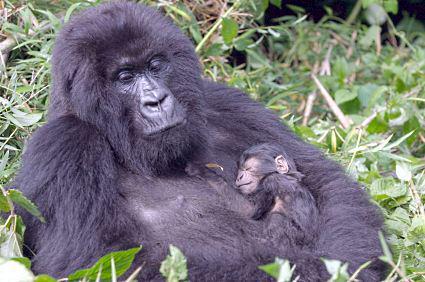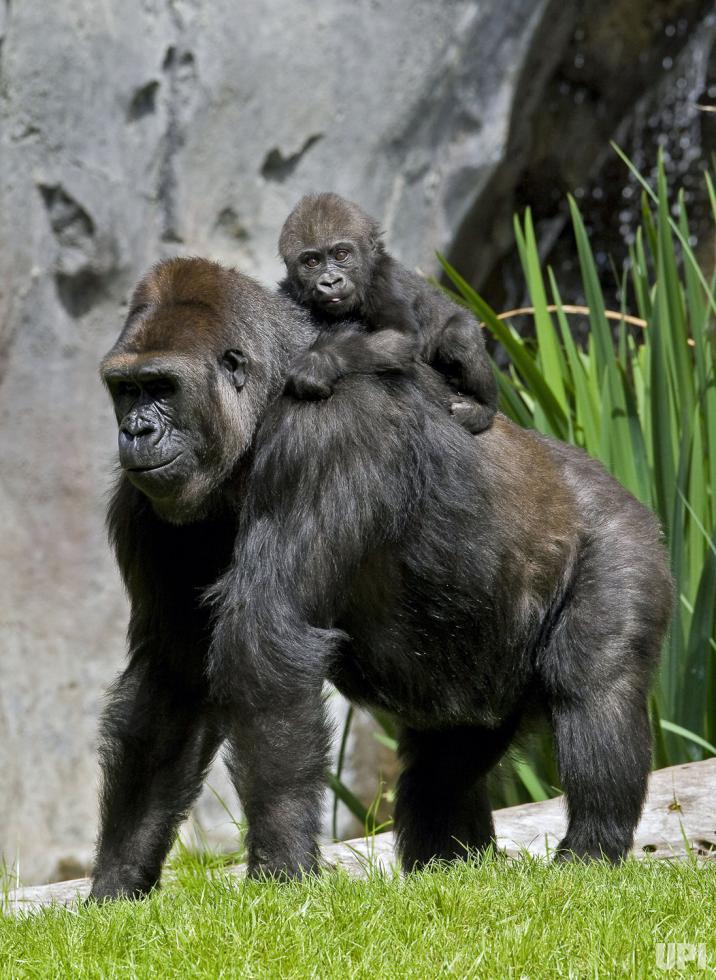The first image is the image on the left, the second image is the image on the right. Given the left and right images, does the statement "Each image features one baby gorilla in contact with one adult gorilla, and one image shows a baby gorilla riding on the back of an adult gorilla." hold true? Answer yes or no. Yes. The first image is the image on the left, the second image is the image on the right. For the images shown, is this caption "Both pictures have an adult gorilla with a young gorilla." true? Answer yes or no. Yes. 